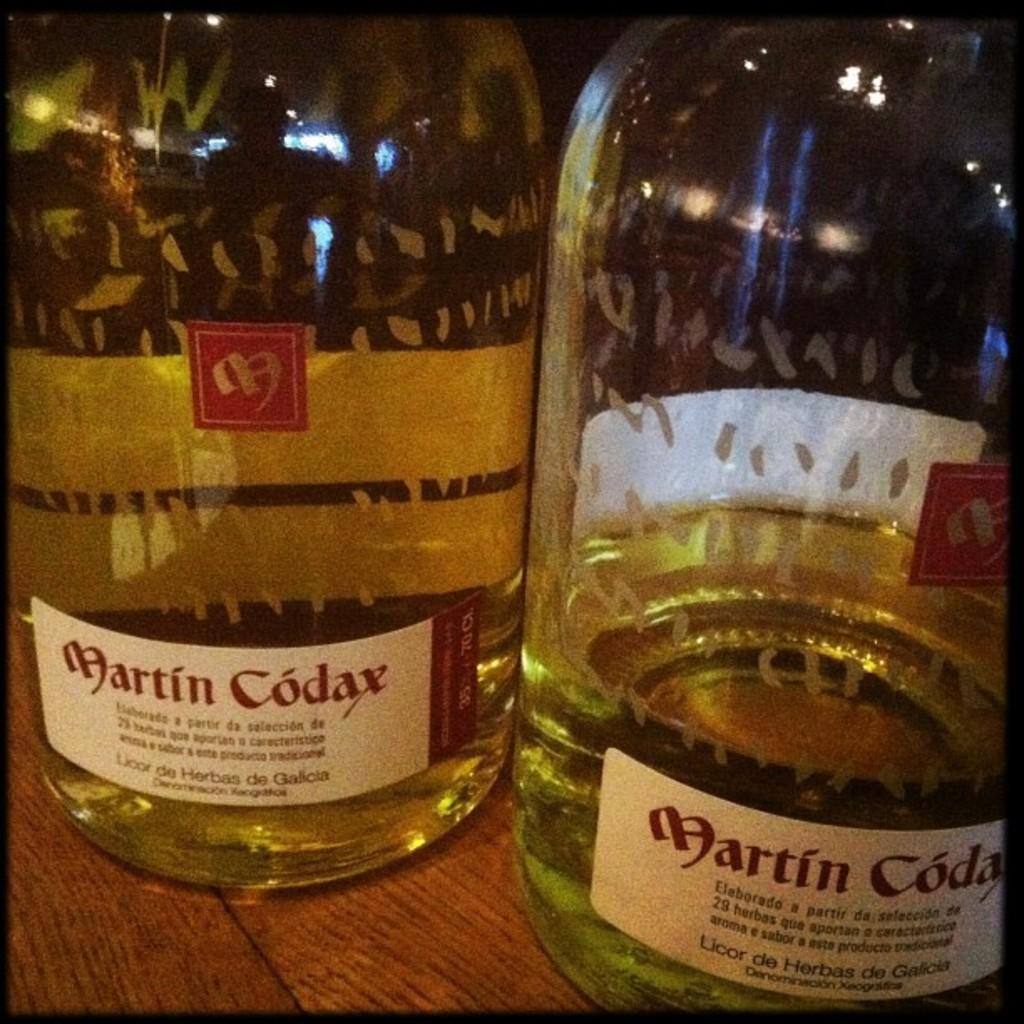<image>
Render a clear and concise summary of the photo. One and half liquid contents of martin codax liquor in two bottles are placed on a table. 